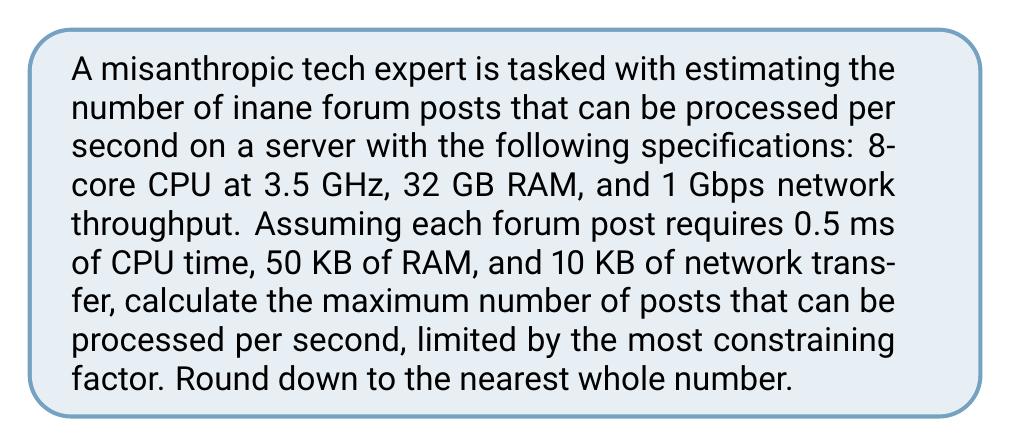Provide a solution to this math problem. Let's analyze each limiting factor:

1. CPU processing:
   - Total CPU cycles per second: $8 \text{ cores} \times 3.5 \times 10^9 \text{ Hz} = 2.8 \times 10^{10} \text{ cycles/s}$
   - CPU time per post: $0.5 \text{ ms} = 0.0005 \text{ s}$
   - Posts processed by CPU: $\frac{2.8 \times 10^{10} \text{ cycles/s}}{0.0005 \text{ s}} = 5.6 \times 10^7 \text{ posts/s}$

2. RAM limitation:
   - Total RAM: $32 \text{ GB} = 32 \times 10^9 \text{ bytes}$
   - RAM per post: $50 \text{ KB} = 5 \times 10^4 \text{ bytes}$
   - Posts limited by RAM: $\frac{32 \times 10^9 \text{ bytes}}{5 \times 10^4 \text{ bytes}} = 6.4 \times 10^5 \text{ posts}$

3. Network throughput:
   - Network speed: $1 \text{ Gbps} = 10^9 \text{ bits/s} = 1.25 \times 10^8 \text{ bytes/s}$
   - Data per post: $10 \text{ KB} = 10^4 \text{ bytes}$
   - Posts limited by network: $\frac{1.25 \times 10^8 \text{ bytes/s}}{10^4 \text{ bytes}} = 1.25 \times 10^4 \text{ posts/s}$

The most constraining factor is the network throughput, limiting the system to 12,500 posts per second. Rounding down, we get 12,500 posts per second.
Answer: 12,500 posts/s 